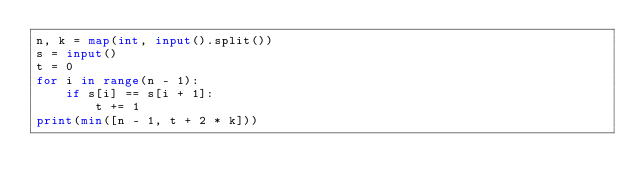<code> <loc_0><loc_0><loc_500><loc_500><_Python_>n, k = map(int, input().split())
s = input()
t = 0
for i in range(n - 1):
    if s[i] == s[i + 1]:
        t += 1
print(min([n - 1, t + 2 * k]))
</code> 